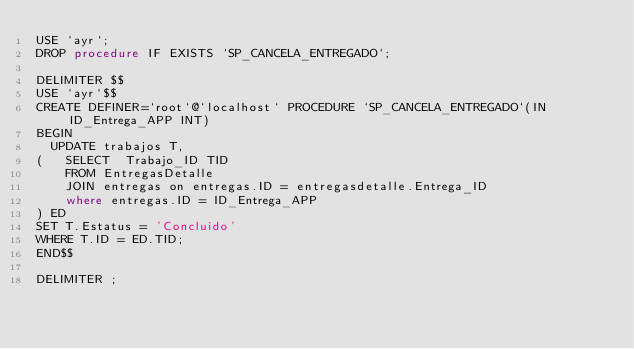Convert code to text. <code><loc_0><loc_0><loc_500><loc_500><_SQL_>USE `ayr`;
DROP procedure IF EXISTS `SP_CANCELA_ENTREGADO`;

DELIMITER $$
USE `ayr`$$
CREATE DEFINER=`root`@`localhost` PROCEDURE `SP_CANCELA_ENTREGADO`(IN ID_Entrega_APP INT)
BEGIN 
	UPDATE trabajos T,
(   SELECT  Trabajo_ID TID
    FROM EntregasDetalle 
    JOIN entregas on entregas.ID = entregasdetalle.Entrega_ID
    where entregas.ID = ID_Entrega_APP
) ED
SET T.Estatus = 'Concluido'
WHERE T.ID = ED.TID;
END$$

DELIMITER ;

</code> 